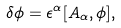Convert formula to latex. <formula><loc_0><loc_0><loc_500><loc_500>\delta \phi = \epsilon ^ { \alpha } [ A _ { \alpha } , \phi ] ,</formula> 